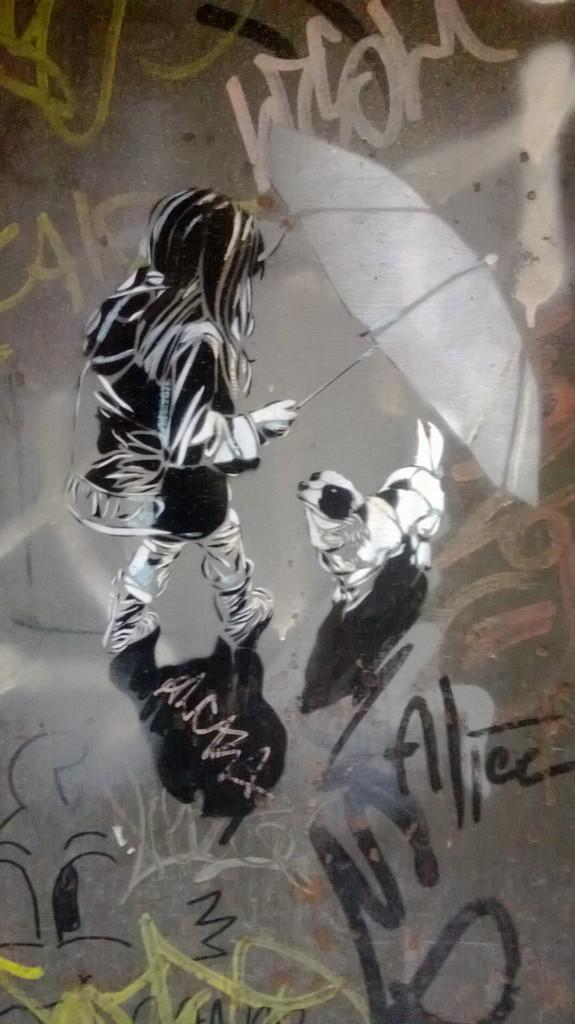What is depicted on the wall in the image? There is graffiti on the wall in the image. What is included in the graffiti? The graffiti includes a sketch of a girl holding an umbrella and a dog. Are there any words or phrases written in the graffiti? Yes, there is text written on the wall in the graffiti. What type of nut is being used as a chair in the image? There is no nut or chair present in the image; it features graffiti with a sketch of a girl holding an umbrella, a dog, and text written on the wall. 